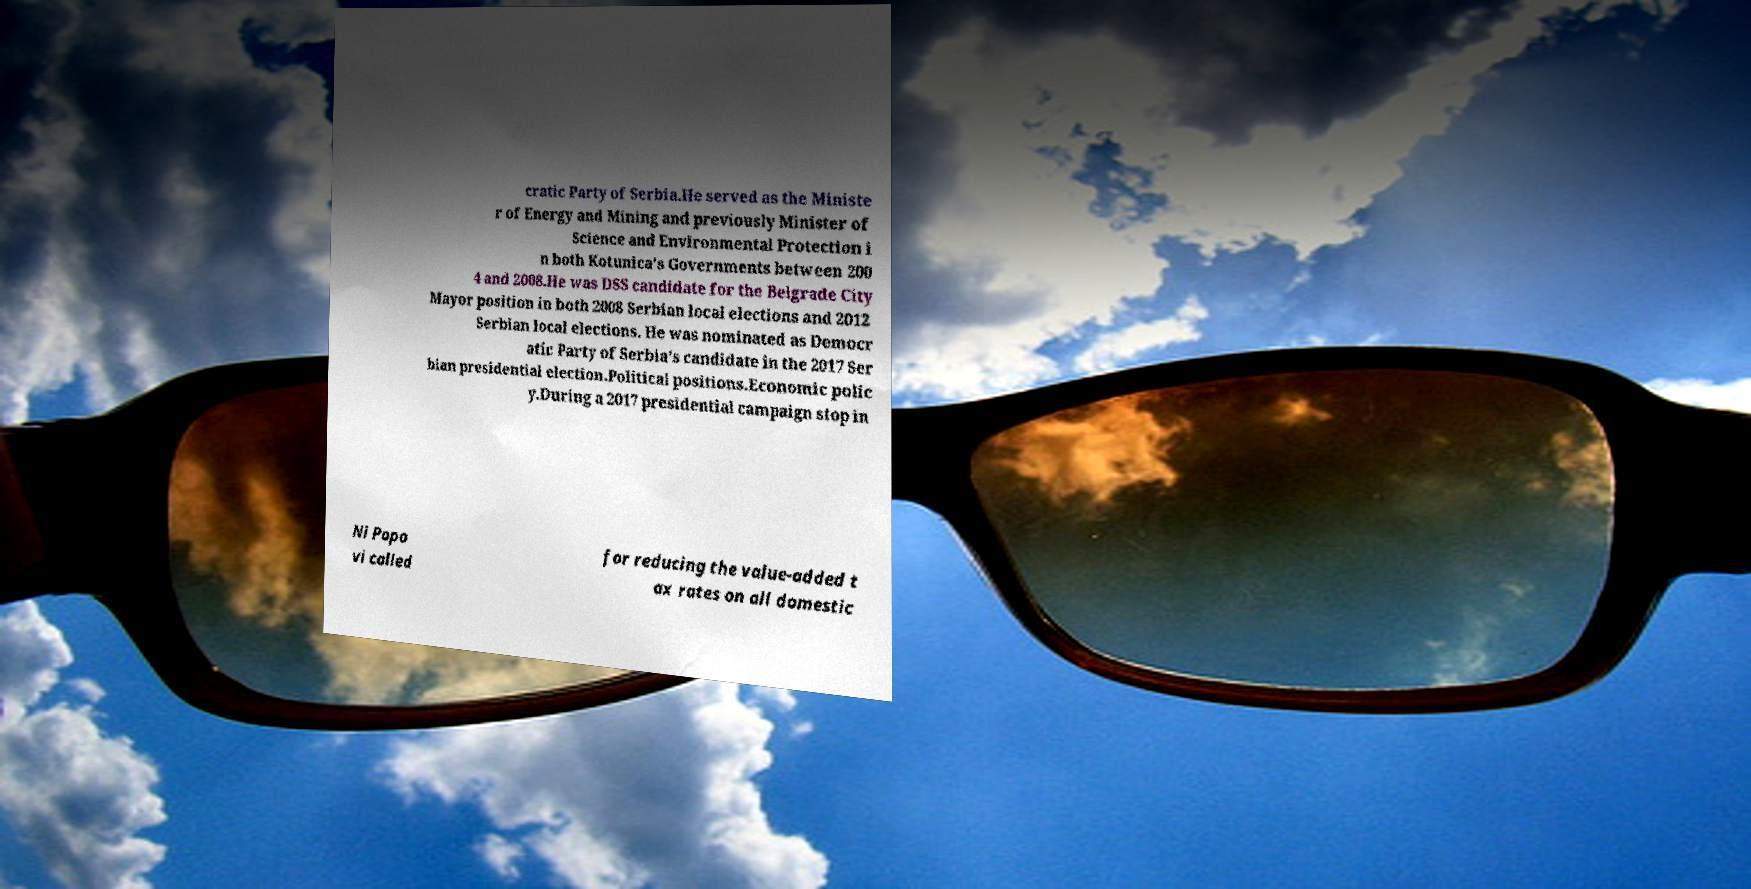For documentation purposes, I need the text within this image transcribed. Could you provide that? cratic Party of Serbia.He served as the Ministe r of Energy and Mining and previously Minister of Science and Environmental Protection i n both Kotunica's Governments between 200 4 and 2008.He was DSS candidate for the Belgrade City Mayor position in both 2008 Serbian local elections and 2012 Serbian local elections. He was nominated as Democr atic Party of Serbia's candidate in the 2017 Ser bian presidential election.Political positions.Economic polic y.During a 2017 presidential campaign stop in Ni Popo vi called for reducing the value-added t ax rates on all domestic 